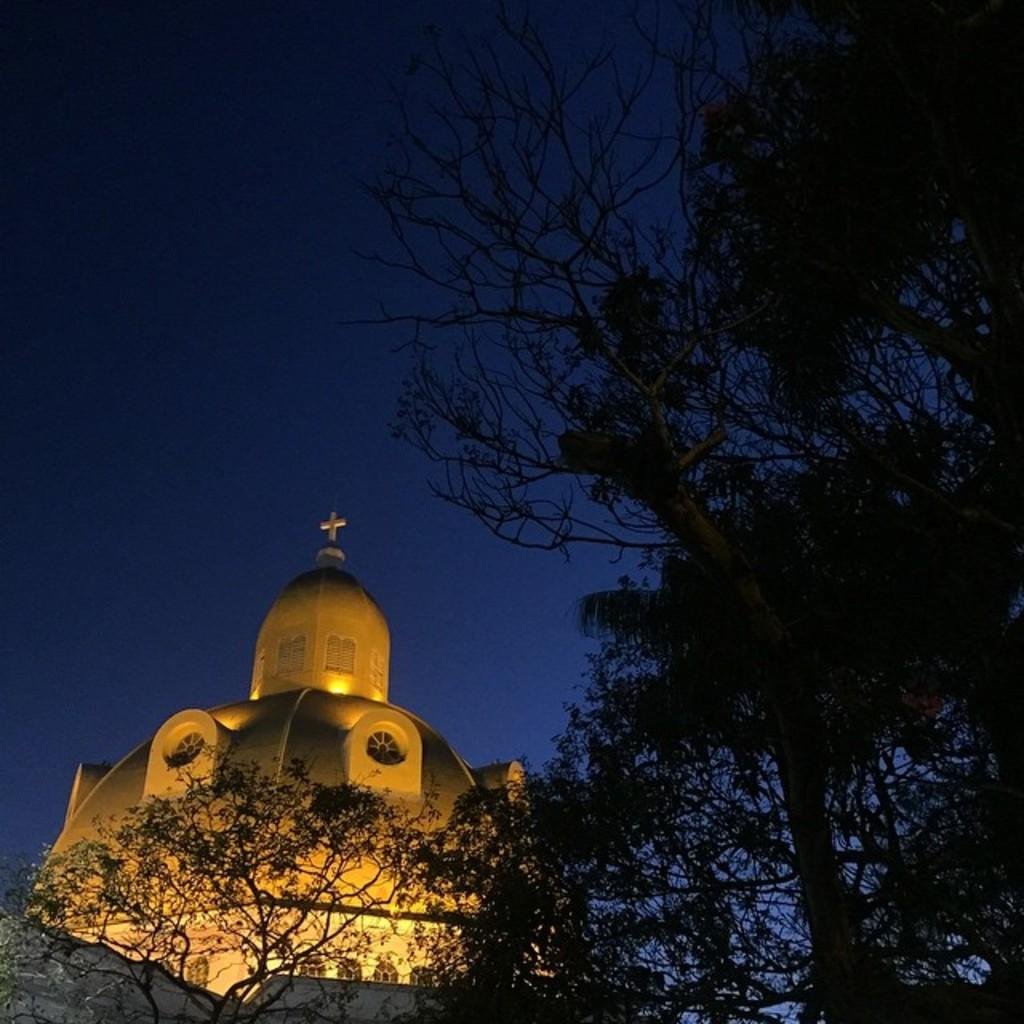What type of vegetation is present in the image? There are many trees in the image. What type of structure can be seen in the image? There is a building in the image. What color is the sky in the background of the image? The sky is blue in the background of the image. What type of locket can be seen hanging from the tree in the image? There is no locket present in the image; only trees and a building are visible. How deep are the roots of the trees in the image? The depth of the tree roots cannot be determined from the image, as the roots are not visible. 